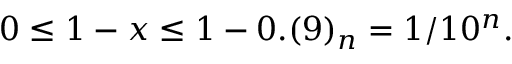Convert formula to latex. <formula><loc_0><loc_0><loc_500><loc_500>0 \leq 1 - x \leq 1 - 0 . ( 9 ) _ { n } = 1 / 1 0 ^ { n } .</formula> 